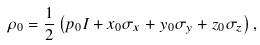Convert formula to latex. <formula><loc_0><loc_0><loc_500><loc_500>\rho _ { 0 } = \frac { 1 } { 2 } \left ( p _ { 0 } I + x _ { 0 } \sigma _ { x } + y _ { 0 } \sigma _ { y } + z _ { 0 } \sigma _ { z } \right ) ,</formula> 